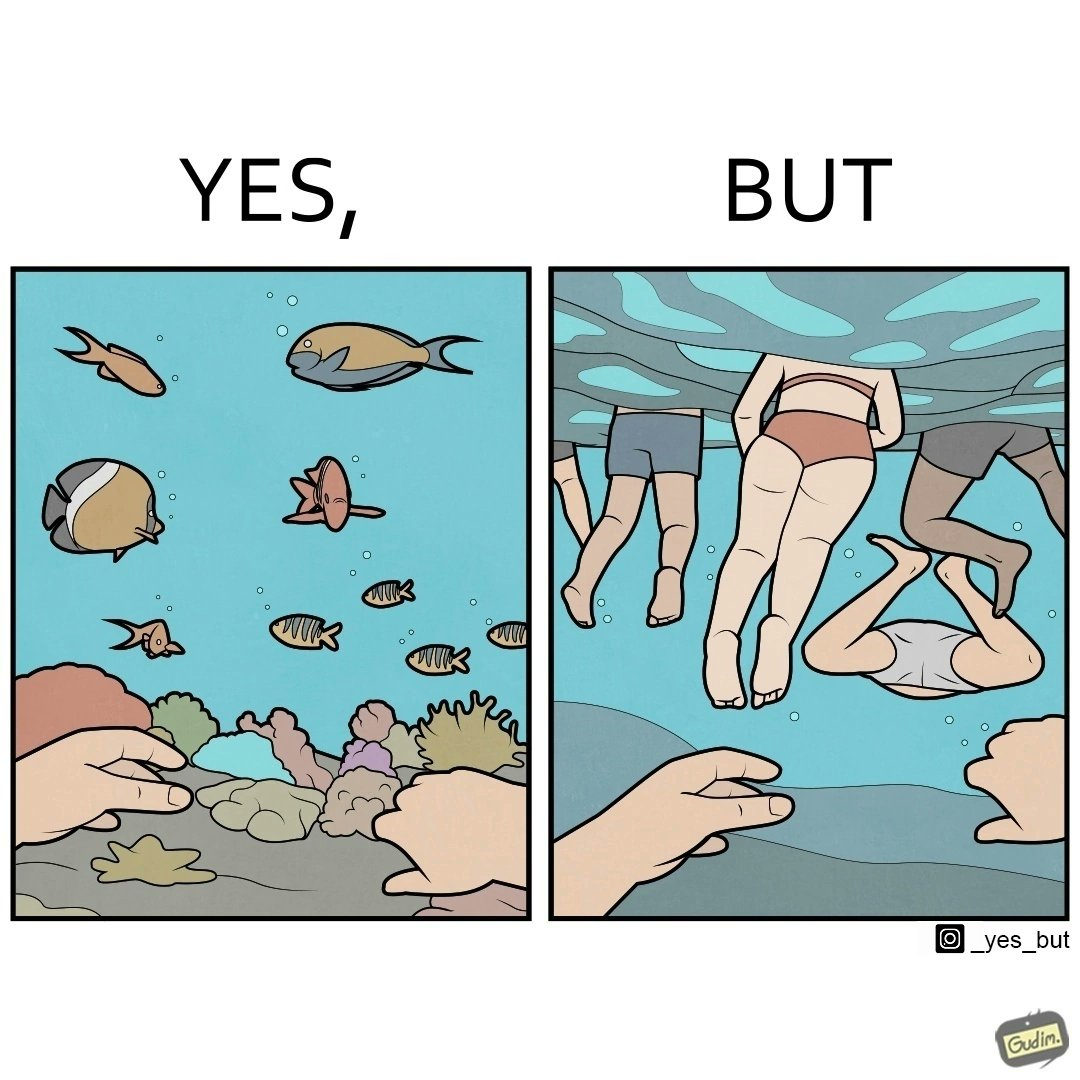Describe the contrast between the left and right parts of this image. In the left part of the image: a person underwater exploring the biodiversity under water In the right part of the image: a person underwater watching people swimming in the water 